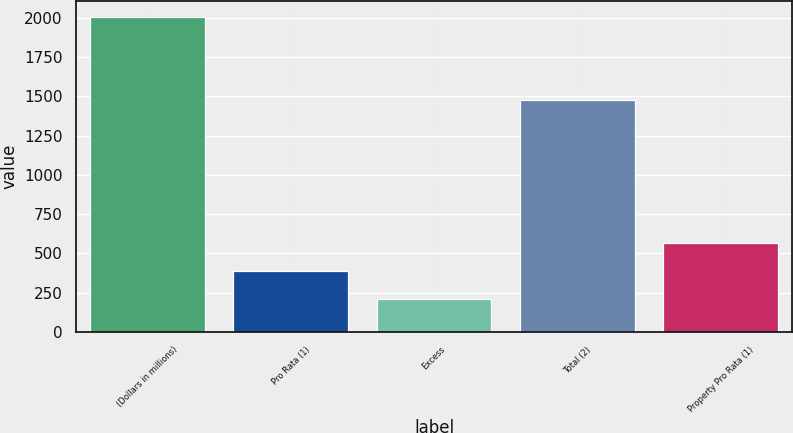Convert chart to OTSL. <chart><loc_0><loc_0><loc_500><loc_500><bar_chart><fcel>(Dollars in millions)<fcel>Pro Rata (1)<fcel>Excess<fcel>Total (2)<fcel>Property Pro Rata (1)<nl><fcel>2004<fcel>388.32<fcel>208.8<fcel>1478.1<fcel>567.84<nl></chart> 